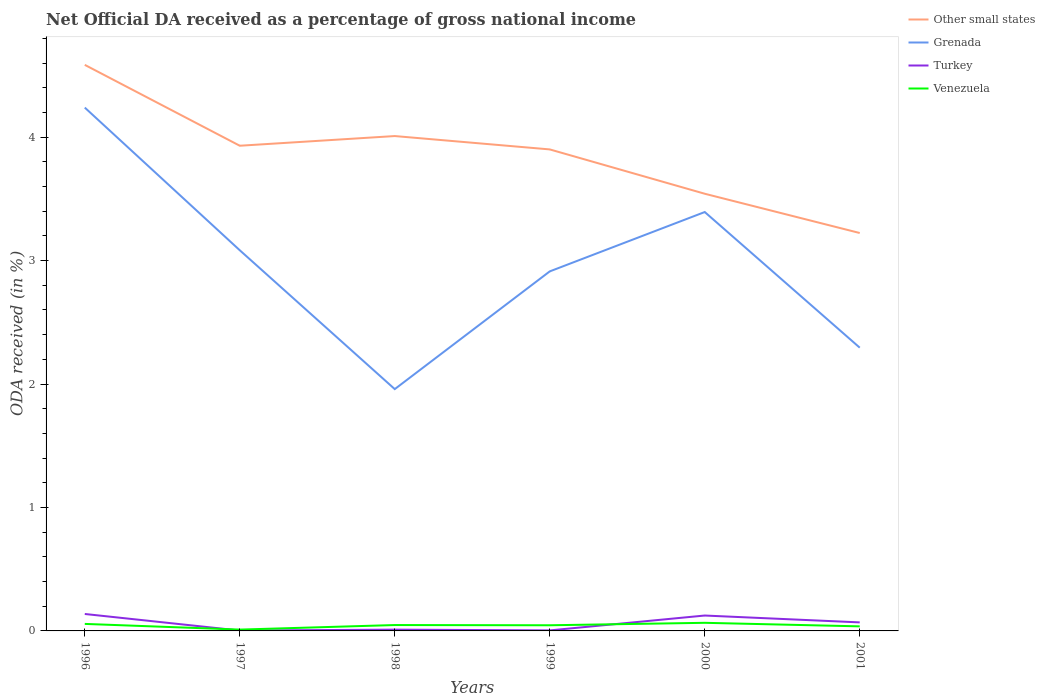How many different coloured lines are there?
Give a very brief answer. 4. Across all years, what is the maximum net official DA received in Turkey?
Provide a succinct answer. 0. In which year was the net official DA received in Other small states maximum?
Your answer should be compact. 2001. What is the total net official DA received in Venezuela in the graph?
Your answer should be very brief. -0.05. What is the difference between the highest and the second highest net official DA received in Grenada?
Offer a terse response. 2.28. What is the difference between the highest and the lowest net official DA received in Other small states?
Your answer should be very brief. 4. Does the graph contain any zero values?
Offer a very short reply. No. How are the legend labels stacked?
Provide a short and direct response. Vertical. What is the title of the graph?
Keep it short and to the point. Net Official DA received as a percentage of gross national income. What is the label or title of the Y-axis?
Your answer should be compact. ODA received (in %). What is the ODA received (in %) of Other small states in 1996?
Ensure brevity in your answer.  4.59. What is the ODA received (in %) of Grenada in 1996?
Your answer should be very brief. 4.24. What is the ODA received (in %) in Turkey in 1996?
Offer a very short reply. 0.14. What is the ODA received (in %) in Venezuela in 1996?
Your response must be concise. 0.06. What is the ODA received (in %) of Other small states in 1997?
Your answer should be compact. 3.93. What is the ODA received (in %) in Grenada in 1997?
Keep it short and to the point. 3.08. What is the ODA received (in %) of Turkey in 1997?
Ensure brevity in your answer.  0. What is the ODA received (in %) in Venezuela in 1997?
Offer a terse response. 0.01. What is the ODA received (in %) in Other small states in 1998?
Your response must be concise. 4.01. What is the ODA received (in %) in Grenada in 1998?
Ensure brevity in your answer.  1.96. What is the ODA received (in %) in Turkey in 1998?
Your answer should be compact. 0.01. What is the ODA received (in %) of Venezuela in 1998?
Offer a terse response. 0.05. What is the ODA received (in %) in Other small states in 1999?
Your answer should be compact. 3.9. What is the ODA received (in %) in Grenada in 1999?
Make the answer very short. 2.91. What is the ODA received (in %) in Turkey in 1999?
Provide a succinct answer. 0. What is the ODA received (in %) of Venezuela in 1999?
Your response must be concise. 0.05. What is the ODA received (in %) of Other small states in 2000?
Ensure brevity in your answer.  3.54. What is the ODA received (in %) in Grenada in 2000?
Keep it short and to the point. 3.39. What is the ODA received (in %) in Turkey in 2000?
Ensure brevity in your answer.  0.12. What is the ODA received (in %) in Venezuela in 2000?
Ensure brevity in your answer.  0.07. What is the ODA received (in %) in Other small states in 2001?
Offer a very short reply. 3.22. What is the ODA received (in %) of Grenada in 2001?
Make the answer very short. 2.29. What is the ODA received (in %) in Turkey in 2001?
Offer a very short reply. 0.07. What is the ODA received (in %) in Venezuela in 2001?
Your answer should be very brief. 0.04. Across all years, what is the maximum ODA received (in %) of Other small states?
Your answer should be very brief. 4.59. Across all years, what is the maximum ODA received (in %) of Grenada?
Offer a terse response. 4.24. Across all years, what is the maximum ODA received (in %) of Turkey?
Keep it short and to the point. 0.14. Across all years, what is the maximum ODA received (in %) in Venezuela?
Ensure brevity in your answer.  0.07. Across all years, what is the minimum ODA received (in %) in Other small states?
Offer a very short reply. 3.22. Across all years, what is the minimum ODA received (in %) of Grenada?
Your answer should be compact. 1.96. Across all years, what is the minimum ODA received (in %) of Turkey?
Your answer should be compact. 0. Across all years, what is the minimum ODA received (in %) in Venezuela?
Provide a short and direct response. 0.01. What is the total ODA received (in %) in Other small states in the graph?
Provide a succinct answer. 23.19. What is the total ODA received (in %) in Grenada in the graph?
Your response must be concise. 17.88. What is the total ODA received (in %) in Turkey in the graph?
Your response must be concise. 0.35. What is the total ODA received (in %) of Venezuela in the graph?
Your answer should be compact. 0.26. What is the difference between the ODA received (in %) in Other small states in 1996 and that in 1997?
Give a very brief answer. 0.66. What is the difference between the ODA received (in %) of Grenada in 1996 and that in 1997?
Your answer should be compact. 1.16. What is the difference between the ODA received (in %) in Turkey in 1996 and that in 1997?
Provide a succinct answer. 0.13. What is the difference between the ODA received (in %) in Venezuela in 1996 and that in 1997?
Keep it short and to the point. 0.05. What is the difference between the ODA received (in %) of Other small states in 1996 and that in 1998?
Your answer should be very brief. 0.58. What is the difference between the ODA received (in %) in Grenada in 1996 and that in 1998?
Your answer should be very brief. 2.28. What is the difference between the ODA received (in %) of Turkey in 1996 and that in 1998?
Provide a succinct answer. 0.13. What is the difference between the ODA received (in %) in Venezuela in 1996 and that in 1998?
Offer a terse response. 0.01. What is the difference between the ODA received (in %) of Other small states in 1996 and that in 1999?
Provide a short and direct response. 0.68. What is the difference between the ODA received (in %) of Grenada in 1996 and that in 1999?
Your response must be concise. 1.33. What is the difference between the ODA received (in %) of Turkey in 1996 and that in 1999?
Your answer should be very brief. 0.13. What is the difference between the ODA received (in %) in Venezuela in 1996 and that in 1999?
Ensure brevity in your answer.  0.01. What is the difference between the ODA received (in %) of Other small states in 1996 and that in 2000?
Your answer should be compact. 1.04. What is the difference between the ODA received (in %) of Grenada in 1996 and that in 2000?
Offer a terse response. 0.85. What is the difference between the ODA received (in %) in Turkey in 1996 and that in 2000?
Your answer should be compact. 0.01. What is the difference between the ODA received (in %) in Venezuela in 1996 and that in 2000?
Give a very brief answer. -0.01. What is the difference between the ODA received (in %) in Other small states in 1996 and that in 2001?
Provide a succinct answer. 1.36. What is the difference between the ODA received (in %) in Grenada in 1996 and that in 2001?
Offer a terse response. 1.94. What is the difference between the ODA received (in %) of Turkey in 1996 and that in 2001?
Give a very brief answer. 0.07. What is the difference between the ODA received (in %) of Venezuela in 1996 and that in 2001?
Provide a succinct answer. 0.02. What is the difference between the ODA received (in %) of Other small states in 1997 and that in 1998?
Your response must be concise. -0.08. What is the difference between the ODA received (in %) in Grenada in 1997 and that in 1998?
Offer a terse response. 1.12. What is the difference between the ODA received (in %) in Turkey in 1997 and that in 1998?
Your answer should be very brief. -0.01. What is the difference between the ODA received (in %) in Venezuela in 1997 and that in 1998?
Provide a succinct answer. -0.04. What is the difference between the ODA received (in %) of Other small states in 1997 and that in 1999?
Provide a short and direct response. 0.03. What is the difference between the ODA received (in %) of Grenada in 1997 and that in 1999?
Your answer should be very brief. 0.17. What is the difference between the ODA received (in %) of Turkey in 1997 and that in 1999?
Offer a very short reply. -0. What is the difference between the ODA received (in %) in Venezuela in 1997 and that in 1999?
Offer a very short reply. -0.04. What is the difference between the ODA received (in %) in Other small states in 1997 and that in 2000?
Provide a short and direct response. 0.39. What is the difference between the ODA received (in %) of Grenada in 1997 and that in 2000?
Your response must be concise. -0.31. What is the difference between the ODA received (in %) of Turkey in 1997 and that in 2000?
Offer a terse response. -0.12. What is the difference between the ODA received (in %) of Venezuela in 1997 and that in 2000?
Your answer should be compact. -0.06. What is the difference between the ODA received (in %) in Other small states in 1997 and that in 2001?
Ensure brevity in your answer.  0.71. What is the difference between the ODA received (in %) in Grenada in 1997 and that in 2001?
Provide a succinct answer. 0.79. What is the difference between the ODA received (in %) in Turkey in 1997 and that in 2001?
Your response must be concise. -0.07. What is the difference between the ODA received (in %) in Venezuela in 1997 and that in 2001?
Make the answer very short. -0.03. What is the difference between the ODA received (in %) of Other small states in 1998 and that in 1999?
Your response must be concise. 0.11. What is the difference between the ODA received (in %) of Grenada in 1998 and that in 1999?
Keep it short and to the point. -0.95. What is the difference between the ODA received (in %) in Turkey in 1998 and that in 1999?
Your answer should be compact. 0.01. What is the difference between the ODA received (in %) in Venezuela in 1998 and that in 1999?
Ensure brevity in your answer.  0. What is the difference between the ODA received (in %) of Other small states in 1998 and that in 2000?
Provide a short and direct response. 0.47. What is the difference between the ODA received (in %) of Grenada in 1998 and that in 2000?
Give a very brief answer. -1.43. What is the difference between the ODA received (in %) of Turkey in 1998 and that in 2000?
Your answer should be compact. -0.11. What is the difference between the ODA received (in %) of Venezuela in 1998 and that in 2000?
Provide a succinct answer. -0.02. What is the difference between the ODA received (in %) of Other small states in 1998 and that in 2001?
Offer a terse response. 0.79. What is the difference between the ODA received (in %) in Grenada in 1998 and that in 2001?
Give a very brief answer. -0.34. What is the difference between the ODA received (in %) of Turkey in 1998 and that in 2001?
Your answer should be compact. -0.06. What is the difference between the ODA received (in %) in Venezuela in 1998 and that in 2001?
Give a very brief answer. 0.01. What is the difference between the ODA received (in %) in Other small states in 1999 and that in 2000?
Make the answer very short. 0.36. What is the difference between the ODA received (in %) in Grenada in 1999 and that in 2000?
Ensure brevity in your answer.  -0.48. What is the difference between the ODA received (in %) of Turkey in 1999 and that in 2000?
Your answer should be compact. -0.12. What is the difference between the ODA received (in %) in Venezuela in 1999 and that in 2000?
Provide a succinct answer. -0.02. What is the difference between the ODA received (in %) in Other small states in 1999 and that in 2001?
Give a very brief answer. 0.68. What is the difference between the ODA received (in %) in Grenada in 1999 and that in 2001?
Give a very brief answer. 0.62. What is the difference between the ODA received (in %) of Turkey in 1999 and that in 2001?
Offer a very short reply. -0.06. What is the difference between the ODA received (in %) in Venezuela in 1999 and that in 2001?
Your response must be concise. 0.01. What is the difference between the ODA received (in %) in Other small states in 2000 and that in 2001?
Make the answer very short. 0.32. What is the difference between the ODA received (in %) of Grenada in 2000 and that in 2001?
Give a very brief answer. 1.1. What is the difference between the ODA received (in %) in Turkey in 2000 and that in 2001?
Ensure brevity in your answer.  0.06. What is the difference between the ODA received (in %) of Venezuela in 2000 and that in 2001?
Make the answer very short. 0.03. What is the difference between the ODA received (in %) of Other small states in 1996 and the ODA received (in %) of Grenada in 1997?
Offer a very short reply. 1.5. What is the difference between the ODA received (in %) of Other small states in 1996 and the ODA received (in %) of Turkey in 1997?
Give a very brief answer. 4.58. What is the difference between the ODA received (in %) in Other small states in 1996 and the ODA received (in %) in Venezuela in 1997?
Your response must be concise. 4.57. What is the difference between the ODA received (in %) of Grenada in 1996 and the ODA received (in %) of Turkey in 1997?
Give a very brief answer. 4.24. What is the difference between the ODA received (in %) in Grenada in 1996 and the ODA received (in %) in Venezuela in 1997?
Your answer should be very brief. 4.23. What is the difference between the ODA received (in %) of Turkey in 1996 and the ODA received (in %) of Venezuela in 1997?
Give a very brief answer. 0.13. What is the difference between the ODA received (in %) in Other small states in 1996 and the ODA received (in %) in Grenada in 1998?
Your answer should be compact. 2.63. What is the difference between the ODA received (in %) in Other small states in 1996 and the ODA received (in %) in Turkey in 1998?
Give a very brief answer. 4.57. What is the difference between the ODA received (in %) of Other small states in 1996 and the ODA received (in %) of Venezuela in 1998?
Ensure brevity in your answer.  4.54. What is the difference between the ODA received (in %) in Grenada in 1996 and the ODA received (in %) in Turkey in 1998?
Your response must be concise. 4.23. What is the difference between the ODA received (in %) of Grenada in 1996 and the ODA received (in %) of Venezuela in 1998?
Offer a very short reply. 4.19. What is the difference between the ODA received (in %) of Turkey in 1996 and the ODA received (in %) of Venezuela in 1998?
Your answer should be very brief. 0.09. What is the difference between the ODA received (in %) of Other small states in 1996 and the ODA received (in %) of Grenada in 1999?
Make the answer very short. 1.67. What is the difference between the ODA received (in %) in Other small states in 1996 and the ODA received (in %) in Turkey in 1999?
Your answer should be compact. 4.58. What is the difference between the ODA received (in %) of Other small states in 1996 and the ODA received (in %) of Venezuela in 1999?
Offer a terse response. 4.54. What is the difference between the ODA received (in %) in Grenada in 1996 and the ODA received (in %) in Turkey in 1999?
Give a very brief answer. 4.23. What is the difference between the ODA received (in %) in Grenada in 1996 and the ODA received (in %) in Venezuela in 1999?
Provide a succinct answer. 4.19. What is the difference between the ODA received (in %) of Turkey in 1996 and the ODA received (in %) of Venezuela in 1999?
Provide a succinct answer. 0.09. What is the difference between the ODA received (in %) in Other small states in 1996 and the ODA received (in %) in Grenada in 2000?
Offer a very short reply. 1.19. What is the difference between the ODA received (in %) in Other small states in 1996 and the ODA received (in %) in Turkey in 2000?
Provide a short and direct response. 4.46. What is the difference between the ODA received (in %) of Other small states in 1996 and the ODA received (in %) of Venezuela in 2000?
Your response must be concise. 4.52. What is the difference between the ODA received (in %) in Grenada in 1996 and the ODA received (in %) in Turkey in 2000?
Ensure brevity in your answer.  4.11. What is the difference between the ODA received (in %) in Grenada in 1996 and the ODA received (in %) in Venezuela in 2000?
Keep it short and to the point. 4.17. What is the difference between the ODA received (in %) of Turkey in 1996 and the ODA received (in %) of Venezuela in 2000?
Your response must be concise. 0.07. What is the difference between the ODA received (in %) in Other small states in 1996 and the ODA received (in %) in Grenada in 2001?
Provide a short and direct response. 2.29. What is the difference between the ODA received (in %) of Other small states in 1996 and the ODA received (in %) of Turkey in 2001?
Your response must be concise. 4.52. What is the difference between the ODA received (in %) in Other small states in 1996 and the ODA received (in %) in Venezuela in 2001?
Give a very brief answer. 4.55. What is the difference between the ODA received (in %) of Grenada in 1996 and the ODA received (in %) of Turkey in 2001?
Provide a succinct answer. 4.17. What is the difference between the ODA received (in %) of Grenada in 1996 and the ODA received (in %) of Venezuela in 2001?
Offer a very short reply. 4.2. What is the difference between the ODA received (in %) of Turkey in 1996 and the ODA received (in %) of Venezuela in 2001?
Give a very brief answer. 0.1. What is the difference between the ODA received (in %) in Other small states in 1997 and the ODA received (in %) in Grenada in 1998?
Offer a very short reply. 1.97. What is the difference between the ODA received (in %) of Other small states in 1997 and the ODA received (in %) of Turkey in 1998?
Give a very brief answer. 3.92. What is the difference between the ODA received (in %) of Other small states in 1997 and the ODA received (in %) of Venezuela in 1998?
Offer a very short reply. 3.88. What is the difference between the ODA received (in %) of Grenada in 1997 and the ODA received (in %) of Turkey in 1998?
Make the answer very short. 3.07. What is the difference between the ODA received (in %) in Grenada in 1997 and the ODA received (in %) in Venezuela in 1998?
Your answer should be compact. 3.04. What is the difference between the ODA received (in %) of Turkey in 1997 and the ODA received (in %) of Venezuela in 1998?
Give a very brief answer. -0.04. What is the difference between the ODA received (in %) in Other small states in 1997 and the ODA received (in %) in Grenada in 1999?
Provide a short and direct response. 1.02. What is the difference between the ODA received (in %) in Other small states in 1997 and the ODA received (in %) in Turkey in 1999?
Make the answer very short. 3.93. What is the difference between the ODA received (in %) in Other small states in 1997 and the ODA received (in %) in Venezuela in 1999?
Ensure brevity in your answer.  3.88. What is the difference between the ODA received (in %) of Grenada in 1997 and the ODA received (in %) of Turkey in 1999?
Make the answer very short. 3.08. What is the difference between the ODA received (in %) in Grenada in 1997 and the ODA received (in %) in Venezuela in 1999?
Make the answer very short. 3.04. What is the difference between the ODA received (in %) of Turkey in 1997 and the ODA received (in %) of Venezuela in 1999?
Keep it short and to the point. -0.04. What is the difference between the ODA received (in %) of Other small states in 1997 and the ODA received (in %) of Grenada in 2000?
Ensure brevity in your answer.  0.54. What is the difference between the ODA received (in %) in Other small states in 1997 and the ODA received (in %) in Turkey in 2000?
Your answer should be compact. 3.81. What is the difference between the ODA received (in %) of Other small states in 1997 and the ODA received (in %) of Venezuela in 2000?
Make the answer very short. 3.86. What is the difference between the ODA received (in %) in Grenada in 1997 and the ODA received (in %) in Turkey in 2000?
Offer a very short reply. 2.96. What is the difference between the ODA received (in %) of Grenada in 1997 and the ODA received (in %) of Venezuela in 2000?
Your answer should be very brief. 3.02. What is the difference between the ODA received (in %) in Turkey in 1997 and the ODA received (in %) in Venezuela in 2000?
Keep it short and to the point. -0.06. What is the difference between the ODA received (in %) in Other small states in 1997 and the ODA received (in %) in Grenada in 2001?
Your answer should be very brief. 1.64. What is the difference between the ODA received (in %) of Other small states in 1997 and the ODA received (in %) of Turkey in 2001?
Make the answer very short. 3.86. What is the difference between the ODA received (in %) in Other small states in 1997 and the ODA received (in %) in Venezuela in 2001?
Provide a short and direct response. 3.89. What is the difference between the ODA received (in %) of Grenada in 1997 and the ODA received (in %) of Turkey in 2001?
Your response must be concise. 3.01. What is the difference between the ODA received (in %) of Grenada in 1997 and the ODA received (in %) of Venezuela in 2001?
Offer a very short reply. 3.05. What is the difference between the ODA received (in %) of Turkey in 1997 and the ODA received (in %) of Venezuela in 2001?
Your response must be concise. -0.03. What is the difference between the ODA received (in %) of Other small states in 1998 and the ODA received (in %) of Grenada in 1999?
Provide a succinct answer. 1.1. What is the difference between the ODA received (in %) in Other small states in 1998 and the ODA received (in %) in Turkey in 1999?
Make the answer very short. 4. What is the difference between the ODA received (in %) in Other small states in 1998 and the ODA received (in %) in Venezuela in 1999?
Make the answer very short. 3.96. What is the difference between the ODA received (in %) in Grenada in 1998 and the ODA received (in %) in Turkey in 1999?
Your answer should be compact. 1.95. What is the difference between the ODA received (in %) in Grenada in 1998 and the ODA received (in %) in Venezuela in 1999?
Your answer should be compact. 1.91. What is the difference between the ODA received (in %) in Turkey in 1998 and the ODA received (in %) in Venezuela in 1999?
Keep it short and to the point. -0.04. What is the difference between the ODA received (in %) of Other small states in 1998 and the ODA received (in %) of Grenada in 2000?
Your response must be concise. 0.62. What is the difference between the ODA received (in %) in Other small states in 1998 and the ODA received (in %) in Turkey in 2000?
Give a very brief answer. 3.88. What is the difference between the ODA received (in %) in Other small states in 1998 and the ODA received (in %) in Venezuela in 2000?
Keep it short and to the point. 3.94. What is the difference between the ODA received (in %) of Grenada in 1998 and the ODA received (in %) of Turkey in 2000?
Your response must be concise. 1.83. What is the difference between the ODA received (in %) in Grenada in 1998 and the ODA received (in %) in Venezuela in 2000?
Provide a succinct answer. 1.89. What is the difference between the ODA received (in %) of Turkey in 1998 and the ODA received (in %) of Venezuela in 2000?
Offer a very short reply. -0.06. What is the difference between the ODA received (in %) in Other small states in 1998 and the ODA received (in %) in Grenada in 2001?
Your response must be concise. 1.71. What is the difference between the ODA received (in %) of Other small states in 1998 and the ODA received (in %) of Turkey in 2001?
Offer a very short reply. 3.94. What is the difference between the ODA received (in %) of Other small states in 1998 and the ODA received (in %) of Venezuela in 2001?
Offer a terse response. 3.97. What is the difference between the ODA received (in %) in Grenada in 1998 and the ODA received (in %) in Turkey in 2001?
Keep it short and to the point. 1.89. What is the difference between the ODA received (in %) in Grenada in 1998 and the ODA received (in %) in Venezuela in 2001?
Your answer should be compact. 1.92. What is the difference between the ODA received (in %) in Turkey in 1998 and the ODA received (in %) in Venezuela in 2001?
Offer a very short reply. -0.03. What is the difference between the ODA received (in %) in Other small states in 1999 and the ODA received (in %) in Grenada in 2000?
Give a very brief answer. 0.51. What is the difference between the ODA received (in %) of Other small states in 1999 and the ODA received (in %) of Turkey in 2000?
Offer a terse response. 3.78. What is the difference between the ODA received (in %) of Other small states in 1999 and the ODA received (in %) of Venezuela in 2000?
Offer a very short reply. 3.83. What is the difference between the ODA received (in %) in Grenada in 1999 and the ODA received (in %) in Turkey in 2000?
Provide a succinct answer. 2.79. What is the difference between the ODA received (in %) of Grenada in 1999 and the ODA received (in %) of Venezuela in 2000?
Offer a very short reply. 2.85. What is the difference between the ODA received (in %) in Turkey in 1999 and the ODA received (in %) in Venezuela in 2000?
Make the answer very short. -0.06. What is the difference between the ODA received (in %) in Other small states in 1999 and the ODA received (in %) in Grenada in 2001?
Ensure brevity in your answer.  1.61. What is the difference between the ODA received (in %) in Other small states in 1999 and the ODA received (in %) in Turkey in 2001?
Make the answer very short. 3.83. What is the difference between the ODA received (in %) of Other small states in 1999 and the ODA received (in %) of Venezuela in 2001?
Your response must be concise. 3.86. What is the difference between the ODA received (in %) of Grenada in 1999 and the ODA received (in %) of Turkey in 2001?
Your answer should be compact. 2.84. What is the difference between the ODA received (in %) of Grenada in 1999 and the ODA received (in %) of Venezuela in 2001?
Provide a short and direct response. 2.88. What is the difference between the ODA received (in %) in Turkey in 1999 and the ODA received (in %) in Venezuela in 2001?
Offer a very short reply. -0.03. What is the difference between the ODA received (in %) in Other small states in 2000 and the ODA received (in %) in Grenada in 2001?
Your answer should be very brief. 1.25. What is the difference between the ODA received (in %) of Other small states in 2000 and the ODA received (in %) of Turkey in 2001?
Your answer should be very brief. 3.47. What is the difference between the ODA received (in %) of Other small states in 2000 and the ODA received (in %) of Venezuela in 2001?
Make the answer very short. 3.5. What is the difference between the ODA received (in %) of Grenada in 2000 and the ODA received (in %) of Turkey in 2001?
Your answer should be compact. 3.32. What is the difference between the ODA received (in %) in Grenada in 2000 and the ODA received (in %) in Venezuela in 2001?
Your response must be concise. 3.36. What is the difference between the ODA received (in %) in Turkey in 2000 and the ODA received (in %) in Venezuela in 2001?
Give a very brief answer. 0.09. What is the average ODA received (in %) in Other small states per year?
Ensure brevity in your answer.  3.86. What is the average ODA received (in %) in Grenada per year?
Provide a succinct answer. 2.98. What is the average ODA received (in %) of Turkey per year?
Give a very brief answer. 0.06. What is the average ODA received (in %) of Venezuela per year?
Ensure brevity in your answer.  0.04. In the year 1996, what is the difference between the ODA received (in %) of Other small states and ODA received (in %) of Grenada?
Your answer should be compact. 0.35. In the year 1996, what is the difference between the ODA received (in %) of Other small states and ODA received (in %) of Turkey?
Your answer should be compact. 4.45. In the year 1996, what is the difference between the ODA received (in %) of Other small states and ODA received (in %) of Venezuela?
Make the answer very short. 4.53. In the year 1996, what is the difference between the ODA received (in %) of Grenada and ODA received (in %) of Turkey?
Keep it short and to the point. 4.1. In the year 1996, what is the difference between the ODA received (in %) of Grenada and ODA received (in %) of Venezuela?
Give a very brief answer. 4.18. In the year 1996, what is the difference between the ODA received (in %) of Turkey and ODA received (in %) of Venezuela?
Your answer should be very brief. 0.08. In the year 1997, what is the difference between the ODA received (in %) of Other small states and ODA received (in %) of Grenada?
Keep it short and to the point. 0.85. In the year 1997, what is the difference between the ODA received (in %) of Other small states and ODA received (in %) of Turkey?
Offer a terse response. 3.93. In the year 1997, what is the difference between the ODA received (in %) in Other small states and ODA received (in %) in Venezuela?
Your answer should be compact. 3.92. In the year 1997, what is the difference between the ODA received (in %) in Grenada and ODA received (in %) in Turkey?
Your answer should be very brief. 3.08. In the year 1997, what is the difference between the ODA received (in %) in Grenada and ODA received (in %) in Venezuela?
Ensure brevity in your answer.  3.07. In the year 1997, what is the difference between the ODA received (in %) in Turkey and ODA received (in %) in Venezuela?
Make the answer very short. -0.01. In the year 1998, what is the difference between the ODA received (in %) in Other small states and ODA received (in %) in Grenada?
Keep it short and to the point. 2.05. In the year 1998, what is the difference between the ODA received (in %) of Other small states and ODA received (in %) of Turkey?
Provide a short and direct response. 4. In the year 1998, what is the difference between the ODA received (in %) of Other small states and ODA received (in %) of Venezuela?
Keep it short and to the point. 3.96. In the year 1998, what is the difference between the ODA received (in %) in Grenada and ODA received (in %) in Turkey?
Offer a very short reply. 1.95. In the year 1998, what is the difference between the ODA received (in %) in Grenada and ODA received (in %) in Venezuela?
Provide a succinct answer. 1.91. In the year 1998, what is the difference between the ODA received (in %) of Turkey and ODA received (in %) of Venezuela?
Provide a short and direct response. -0.04. In the year 1999, what is the difference between the ODA received (in %) in Other small states and ODA received (in %) in Turkey?
Keep it short and to the point. 3.9. In the year 1999, what is the difference between the ODA received (in %) of Other small states and ODA received (in %) of Venezuela?
Keep it short and to the point. 3.85. In the year 1999, what is the difference between the ODA received (in %) in Grenada and ODA received (in %) in Turkey?
Offer a very short reply. 2.91. In the year 1999, what is the difference between the ODA received (in %) in Grenada and ODA received (in %) in Venezuela?
Offer a very short reply. 2.87. In the year 1999, what is the difference between the ODA received (in %) of Turkey and ODA received (in %) of Venezuela?
Your answer should be compact. -0.04. In the year 2000, what is the difference between the ODA received (in %) in Other small states and ODA received (in %) in Grenada?
Give a very brief answer. 0.15. In the year 2000, what is the difference between the ODA received (in %) in Other small states and ODA received (in %) in Turkey?
Offer a very short reply. 3.42. In the year 2000, what is the difference between the ODA received (in %) in Other small states and ODA received (in %) in Venezuela?
Your response must be concise. 3.48. In the year 2000, what is the difference between the ODA received (in %) in Grenada and ODA received (in %) in Turkey?
Ensure brevity in your answer.  3.27. In the year 2000, what is the difference between the ODA received (in %) of Grenada and ODA received (in %) of Venezuela?
Keep it short and to the point. 3.33. In the year 2000, what is the difference between the ODA received (in %) in Turkey and ODA received (in %) in Venezuela?
Offer a terse response. 0.06. In the year 2001, what is the difference between the ODA received (in %) in Other small states and ODA received (in %) in Grenada?
Your answer should be compact. 0.93. In the year 2001, what is the difference between the ODA received (in %) of Other small states and ODA received (in %) of Turkey?
Your answer should be very brief. 3.15. In the year 2001, what is the difference between the ODA received (in %) of Other small states and ODA received (in %) of Venezuela?
Give a very brief answer. 3.19. In the year 2001, what is the difference between the ODA received (in %) of Grenada and ODA received (in %) of Turkey?
Your answer should be compact. 2.23. In the year 2001, what is the difference between the ODA received (in %) in Grenada and ODA received (in %) in Venezuela?
Make the answer very short. 2.26. In the year 2001, what is the difference between the ODA received (in %) of Turkey and ODA received (in %) of Venezuela?
Give a very brief answer. 0.03. What is the ratio of the ODA received (in %) in Grenada in 1996 to that in 1997?
Offer a very short reply. 1.37. What is the ratio of the ODA received (in %) in Turkey in 1996 to that in 1997?
Provide a succinct answer. 44.67. What is the ratio of the ODA received (in %) of Venezuela in 1996 to that in 1997?
Provide a short and direct response. 5.3. What is the ratio of the ODA received (in %) in Other small states in 1996 to that in 1998?
Provide a short and direct response. 1.14. What is the ratio of the ODA received (in %) in Grenada in 1996 to that in 1998?
Your response must be concise. 2.16. What is the ratio of the ODA received (in %) in Turkey in 1996 to that in 1998?
Make the answer very short. 12.99. What is the ratio of the ODA received (in %) in Venezuela in 1996 to that in 1998?
Offer a very short reply. 1.19. What is the ratio of the ODA received (in %) in Other small states in 1996 to that in 1999?
Offer a terse response. 1.18. What is the ratio of the ODA received (in %) in Grenada in 1996 to that in 1999?
Provide a short and direct response. 1.46. What is the ratio of the ODA received (in %) of Turkey in 1996 to that in 1999?
Your response must be concise. 32.26. What is the ratio of the ODA received (in %) of Venezuela in 1996 to that in 1999?
Your response must be concise. 1.24. What is the ratio of the ODA received (in %) of Other small states in 1996 to that in 2000?
Give a very brief answer. 1.29. What is the ratio of the ODA received (in %) in Grenada in 1996 to that in 2000?
Offer a terse response. 1.25. What is the ratio of the ODA received (in %) of Turkey in 1996 to that in 2000?
Ensure brevity in your answer.  1.1. What is the ratio of the ODA received (in %) in Venezuela in 1996 to that in 2000?
Give a very brief answer. 0.86. What is the ratio of the ODA received (in %) of Other small states in 1996 to that in 2001?
Provide a short and direct response. 1.42. What is the ratio of the ODA received (in %) in Grenada in 1996 to that in 2001?
Your answer should be compact. 1.85. What is the ratio of the ODA received (in %) in Turkey in 1996 to that in 2001?
Keep it short and to the point. 1.99. What is the ratio of the ODA received (in %) of Venezuela in 1996 to that in 2001?
Make the answer very short. 1.54. What is the ratio of the ODA received (in %) in Other small states in 1997 to that in 1998?
Provide a short and direct response. 0.98. What is the ratio of the ODA received (in %) of Grenada in 1997 to that in 1998?
Keep it short and to the point. 1.57. What is the ratio of the ODA received (in %) in Turkey in 1997 to that in 1998?
Make the answer very short. 0.29. What is the ratio of the ODA received (in %) in Venezuela in 1997 to that in 1998?
Ensure brevity in your answer.  0.22. What is the ratio of the ODA received (in %) of Other small states in 1997 to that in 1999?
Offer a terse response. 1.01. What is the ratio of the ODA received (in %) of Grenada in 1997 to that in 1999?
Make the answer very short. 1.06. What is the ratio of the ODA received (in %) of Turkey in 1997 to that in 1999?
Provide a short and direct response. 0.72. What is the ratio of the ODA received (in %) of Venezuela in 1997 to that in 1999?
Give a very brief answer. 0.23. What is the ratio of the ODA received (in %) of Other small states in 1997 to that in 2000?
Provide a short and direct response. 1.11. What is the ratio of the ODA received (in %) of Grenada in 1997 to that in 2000?
Make the answer very short. 0.91. What is the ratio of the ODA received (in %) in Turkey in 1997 to that in 2000?
Ensure brevity in your answer.  0.02. What is the ratio of the ODA received (in %) in Venezuela in 1997 to that in 2000?
Keep it short and to the point. 0.16. What is the ratio of the ODA received (in %) in Other small states in 1997 to that in 2001?
Make the answer very short. 1.22. What is the ratio of the ODA received (in %) in Grenada in 1997 to that in 2001?
Provide a succinct answer. 1.34. What is the ratio of the ODA received (in %) in Turkey in 1997 to that in 2001?
Offer a very short reply. 0.04. What is the ratio of the ODA received (in %) of Venezuela in 1997 to that in 2001?
Your answer should be compact. 0.29. What is the ratio of the ODA received (in %) in Other small states in 1998 to that in 1999?
Provide a short and direct response. 1.03. What is the ratio of the ODA received (in %) in Grenada in 1998 to that in 1999?
Offer a very short reply. 0.67. What is the ratio of the ODA received (in %) of Turkey in 1998 to that in 1999?
Your response must be concise. 2.48. What is the ratio of the ODA received (in %) of Venezuela in 1998 to that in 1999?
Ensure brevity in your answer.  1.04. What is the ratio of the ODA received (in %) of Other small states in 1998 to that in 2000?
Make the answer very short. 1.13. What is the ratio of the ODA received (in %) in Grenada in 1998 to that in 2000?
Keep it short and to the point. 0.58. What is the ratio of the ODA received (in %) of Turkey in 1998 to that in 2000?
Provide a short and direct response. 0.08. What is the ratio of the ODA received (in %) of Venezuela in 1998 to that in 2000?
Your response must be concise. 0.72. What is the ratio of the ODA received (in %) of Other small states in 1998 to that in 2001?
Your response must be concise. 1.24. What is the ratio of the ODA received (in %) of Grenada in 1998 to that in 2001?
Make the answer very short. 0.85. What is the ratio of the ODA received (in %) of Turkey in 1998 to that in 2001?
Keep it short and to the point. 0.15. What is the ratio of the ODA received (in %) of Venezuela in 1998 to that in 2001?
Your answer should be very brief. 1.29. What is the ratio of the ODA received (in %) of Other small states in 1999 to that in 2000?
Offer a terse response. 1.1. What is the ratio of the ODA received (in %) in Grenada in 1999 to that in 2000?
Provide a succinct answer. 0.86. What is the ratio of the ODA received (in %) of Turkey in 1999 to that in 2000?
Make the answer very short. 0.03. What is the ratio of the ODA received (in %) of Venezuela in 1999 to that in 2000?
Your answer should be compact. 0.7. What is the ratio of the ODA received (in %) in Other small states in 1999 to that in 2001?
Your answer should be compact. 1.21. What is the ratio of the ODA received (in %) of Grenada in 1999 to that in 2001?
Your answer should be very brief. 1.27. What is the ratio of the ODA received (in %) of Turkey in 1999 to that in 2001?
Your response must be concise. 0.06. What is the ratio of the ODA received (in %) of Venezuela in 1999 to that in 2001?
Your answer should be compact. 1.24. What is the ratio of the ODA received (in %) of Other small states in 2000 to that in 2001?
Give a very brief answer. 1.1. What is the ratio of the ODA received (in %) in Grenada in 2000 to that in 2001?
Offer a very short reply. 1.48. What is the ratio of the ODA received (in %) of Turkey in 2000 to that in 2001?
Give a very brief answer. 1.81. What is the ratio of the ODA received (in %) in Venezuela in 2000 to that in 2001?
Offer a very short reply. 1.78. What is the difference between the highest and the second highest ODA received (in %) in Other small states?
Offer a terse response. 0.58. What is the difference between the highest and the second highest ODA received (in %) in Grenada?
Provide a short and direct response. 0.85. What is the difference between the highest and the second highest ODA received (in %) of Turkey?
Your answer should be very brief. 0.01. What is the difference between the highest and the second highest ODA received (in %) of Venezuela?
Your answer should be very brief. 0.01. What is the difference between the highest and the lowest ODA received (in %) of Other small states?
Offer a very short reply. 1.36. What is the difference between the highest and the lowest ODA received (in %) of Grenada?
Your answer should be very brief. 2.28. What is the difference between the highest and the lowest ODA received (in %) in Turkey?
Provide a succinct answer. 0.13. What is the difference between the highest and the lowest ODA received (in %) in Venezuela?
Offer a terse response. 0.06. 